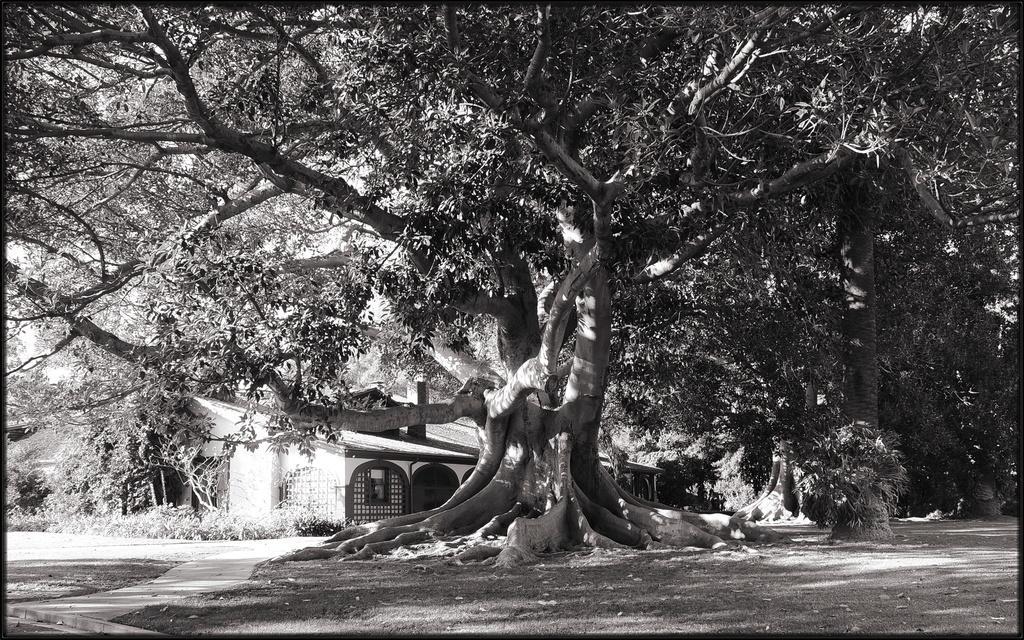Describe this image in one or two sentences. It is the black and white image in which there is a big tree in the middle. Behind the tree there is a house. At the bottom there is ground. 